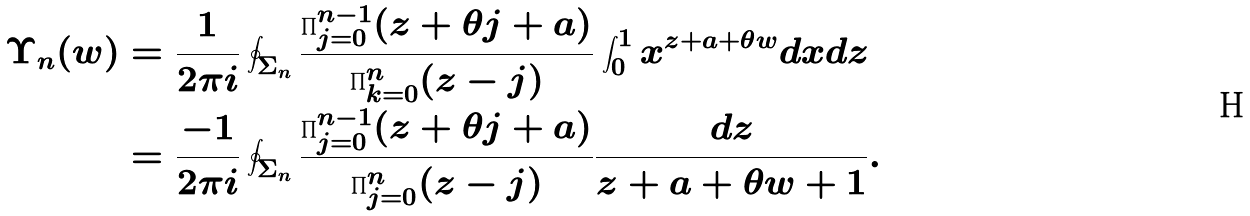Convert formula to latex. <formula><loc_0><loc_0><loc_500><loc_500>\Upsilon _ { n } ( w ) & = \frac { 1 } { 2 \pi i } \oint _ { \Sigma _ { n } } \frac { \prod _ { j = 0 } ^ { n - 1 } ( z + \theta j + a ) } { \prod _ { k = 0 } ^ { n } ( z - j ) } \int _ { 0 } ^ { 1 } x ^ { z + a + \theta w } d x d z \\ & = \frac { - 1 } { 2 \pi i } \oint _ { \Sigma _ { n } } \frac { \prod _ { j = 0 } ^ { n - 1 } ( z + \theta j + a ) } { \prod _ { j = 0 } ^ { n } ( z - j ) } \frac { d z } { z + a + \theta w + 1 } .</formula> 